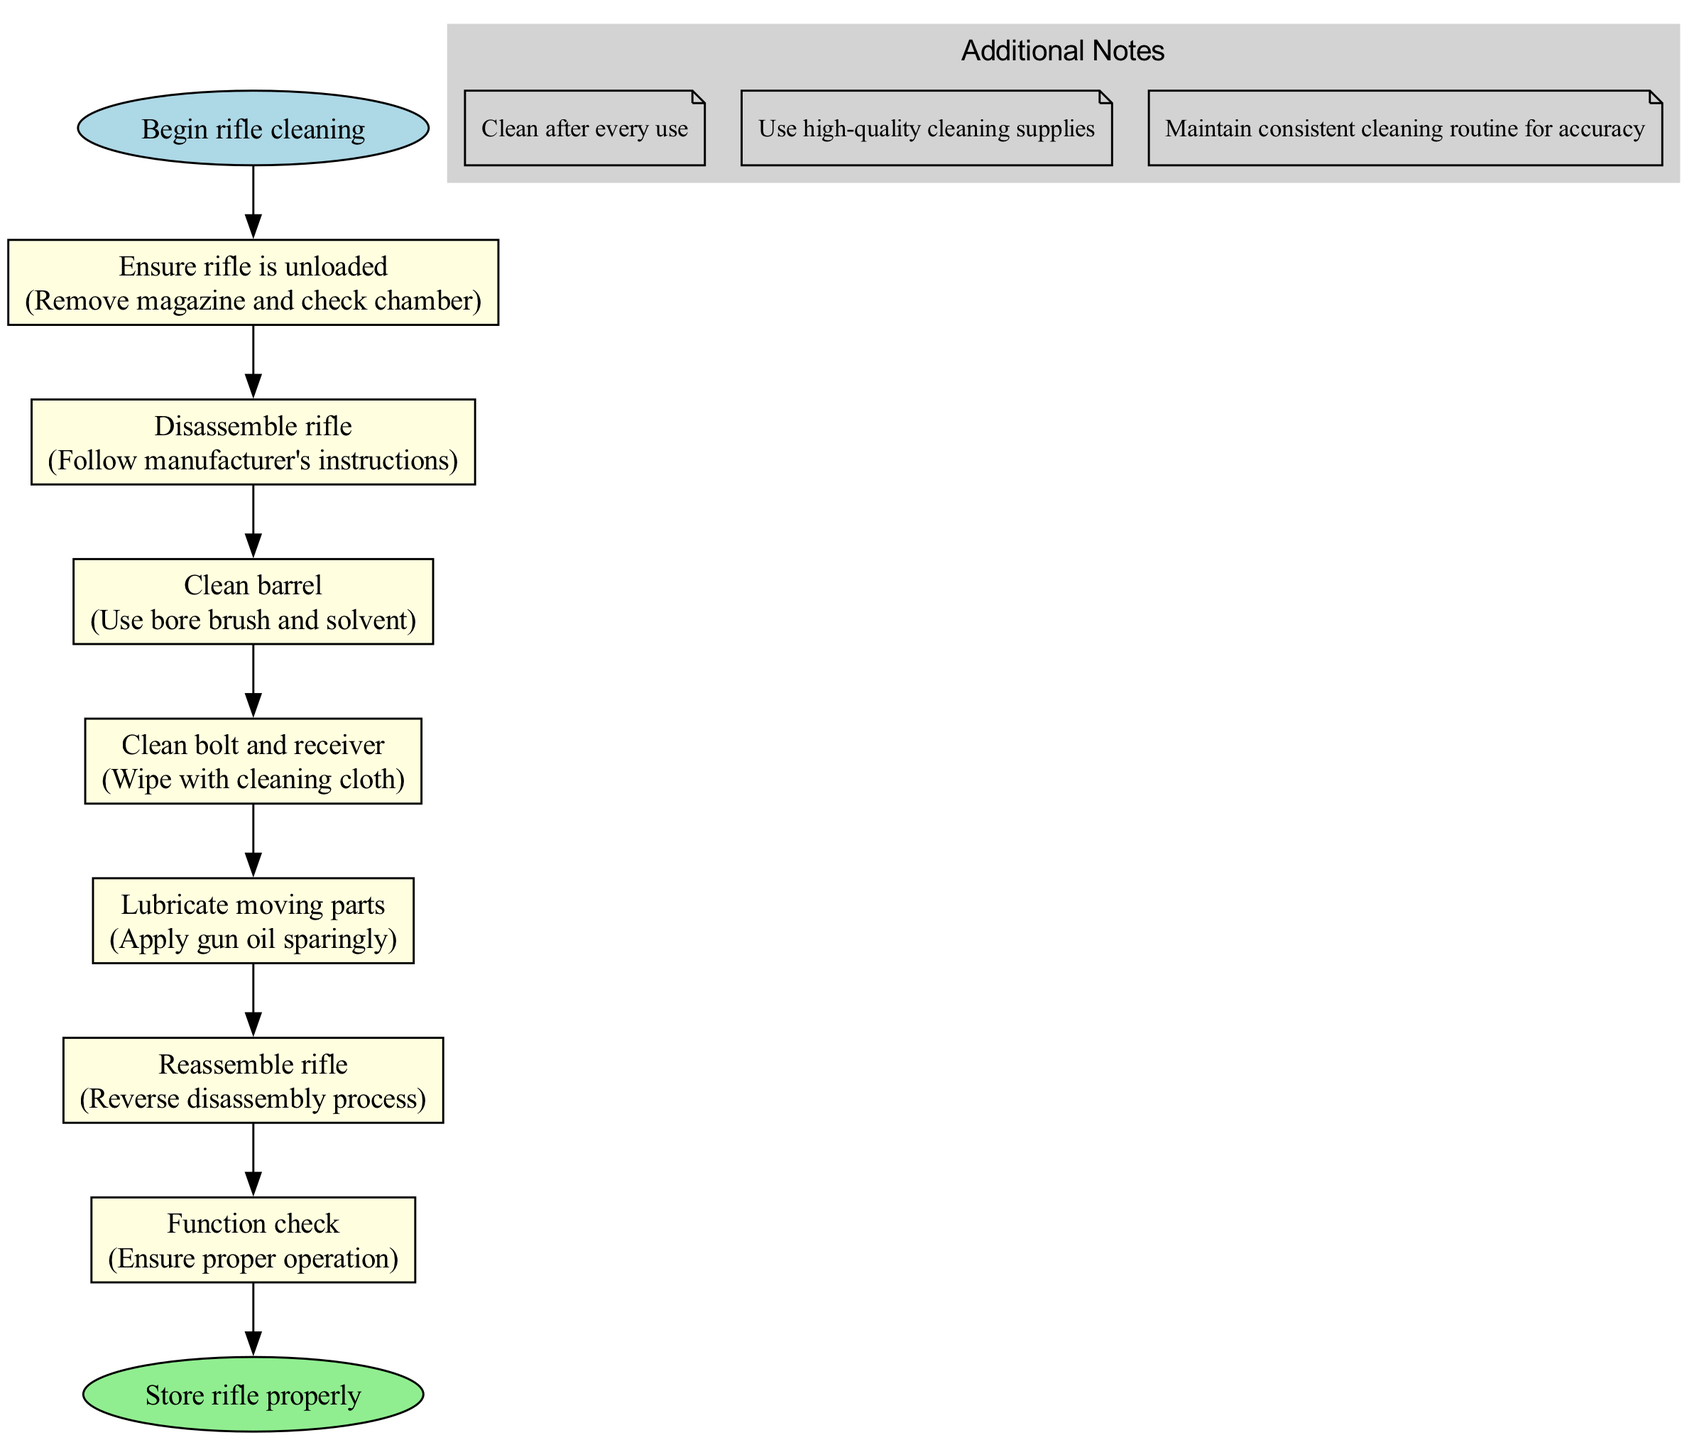What is the first step in the rifle cleaning process? The diagram indicates that the first step is to "Ensure rifle is unloaded". It is listed as the first node that follows the starting point of the flowchart.
Answer: Ensure rifle is unloaded How many steps are there in the cleaning process? The diagram shows a total of six steps, leading up to the end node. Each step is connected sequentially from start to finish.
Answer: Six What do you do after cleaning the barrel? The sequence indicates that after cleaning the barrel, the next step is to "Clean bolt and receiver". This follows directly from the step of cleaning the barrel.
Answer: Clean bolt and receiver What is the last action before storing the rifle? The last action specified in the flowchart is "Function check", which comes right before the final storage instruction. It ensures that the rifle operates properly after maintenance.
Answer: Function check Which step involves applying gun oil? The step that involves applying gun oil is "Lubricate moving parts", which specifically mentions using gun oil sparingly.
Answer: Lubricate moving parts What color are the step nodes in the flowchart? The step nodes are colored light yellow, as indicated in the visual representation of the diagram. This color is used consistently for all steps within the cleaning process.
Answer: Light yellow How is the relationship between "Disassemble rifle" and "Reassemble rifle"? The relationship between these two nodes is binary: "Disassemble rifle" is connected to "Reassemble rifle" as they are sequential actions. You must disassemble before reassembling.
Answer: Sequential actions What is a recommendation for cleaning supplies? The additional note states to "Use high-quality cleaning supplies", indicating the importance of using good materials for maintenance.
Answer: Use high-quality cleaning supplies 